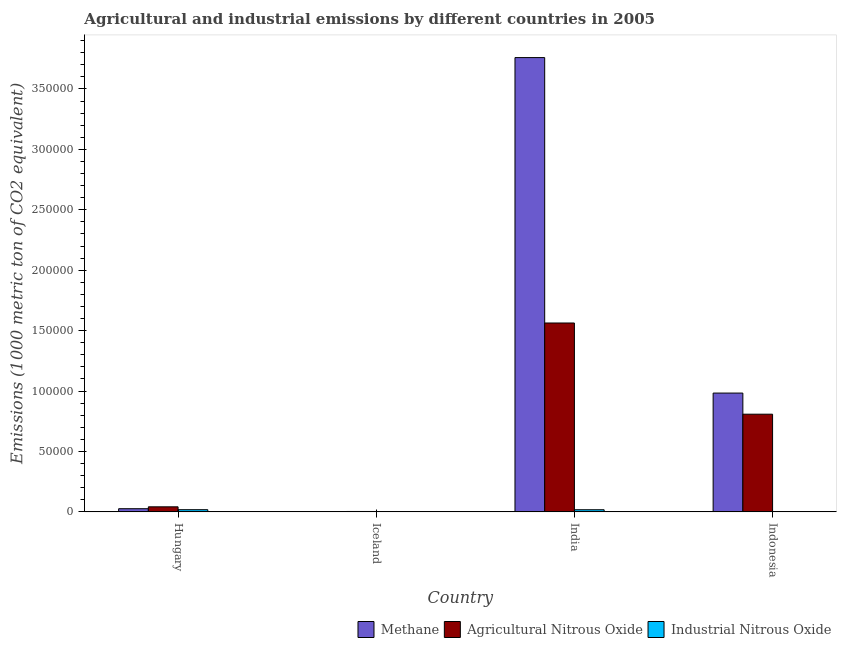How many different coloured bars are there?
Make the answer very short. 3. Are the number of bars per tick equal to the number of legend labels?
Ensure brevity in your answer.  Yes. Are the number of bars on each tick of the X-axis equal?
Keep it short and to the point. Yes. How many bars are there on the 4th tick from the right?
Provide a short and direct response. 3. What is the label of the 4th group of bars from the left?
Your response must be concise. Indonesia. In how many cases, is the number of bars for a given country not equal to the number of legend labels?
Provide a short and direct response. 0. What is the amount of industrial nitrous oxide emissions in Indonesia?
Your answer should be compact. 219.6. Across all countries, what is the maximum amount of industrial nitrous oxide emissions?
Ensure brevity in your answer.  1802. Across all countries, what is the minimum amount of methane emissions?
Provide a short and direct response. 214.9. In which country was the amount of methane emissions maximum?
Give a very brief answer. India. What is the total amount of industrial nitrous oxide emissions in the graph?
Your answer should be compact. 3798.8. What is the difference between the amount of methane emissions in India and that in Indonesia?
Offer a very short reply. 2.78e+05. What is the difference between the amount of industrial nitrous oxide emissions in Indonesia and the amount of methane emissions in Hungary?
Make the answer very short. -2393.4. What is the average amount of agricultural nitrous oxide emissions per country?
Give a very brief answer. 6.04e+04. What is the difference between the amount of methane emissions and amount of industrial nitrous oxide emissions in India?
Your answer should be very brief. 3.74e+05. What is the ratio of the amount of industrial nitrous oxide emissions in Iceland to that in Indonesia?
Your answer should be very brief. 0.07. Is the difference between the amount of industrial nitrous oxide emissions in Iceland and Indonesia greater than the difference between the amount of agricultural nitrous oxide emissions in Iceland and Indonesia?
Ensure brevity in your answer.  Yes. What is the difference between the highest and the second highest amount of agricultural nitrous oxide emissions?
Make the answer very short. 7.55e+04. What is the difference between the highest and the lowest amount of methane emissions?
Give a very brief answer. 3.76e+05. In how many countries, is the amount of agricultural nitrous oxide emissions greater than the average amount of agricultural nitrous oxide emissions taken over all countries?
Your answer should be very brief. 2. Is the sum of the amount of methane emissions in Hungary and Iceland greater than the maximum amount of industrial nitrous oxide emissions across all countries?
Offer a very short reply. Yes. What does the 1st bar from the left in Hungary represents?
Provide a succinct answer. Methane. What does the 1st bar from the right in Iceland represents?
Provide a short and direct response. Industrial Nitrous Oxide. How many bars are there?
Your answer should be very brief. 12. Are all the bars in the graph horizontal?
Provide a succinct answer. No. What is the difference between two consecutive major ticks on the Y-axis?
Provide a short and direct response. 5.00e+04. Are the values on the major ticks of Y-axis written in scientific E-notation?
Offer a terse response. No. Does the graph contain any zero values?
Provide a short and direct response. No. Does the graph contain grids?
Provide a short and direct response. No. How are the legend labels stacked?
Provide a short and direct response. Horizontal. What is the title of the graph?
Ensure brevity in your answer.  Agricultural and industrial emissions by different countries in 2005. What is the label or title of the Y-axis?
Offer a very short reply. Emissions (1000 metric ton of CO2 equivalent). What is the Emissions (1000 metric ton of CO2 equivalent) of Methane in Hungary?
Offer a terse response. 2613. What is the Emissions (1000 metric ton of CO2 equivalent) of Agricultural Nitrous Oxide in Hungary?
Your response must be concise. 4181.2. What is the Emissions (1000 metric ton of CO2 equivalent) of Industrial Nitrous Oxide in Hungary?
Provide a succinct answer. 1802. What is the Emissions (1000 metric ton of CO2 equivalent) of Methane in Iceland?
Ensure brevity in your answer.  214.9. What is the Emissions (1000 metric ton of CO2 equivalent) of Agricultural Nitrous Oxide in Iceland?
Your answer should be compact. 332.8. What is the Emissions (1000 metric ton of CO2 equivalent) of Industrial Nitrous Oxide in Iceland?
Your answer should be very brief. 15.3. What is the Emissions (1000 metric ton of CO2 equivalent) in Methane in India?
Give a very brief answer. 3.76e+05. What is the Emissions (1000 metric ton of CO2 equivalent) of Agricultural Nitrous Oxide in India?
Provide a short and direct response. 1.56e+05. What is the Emissions (1000 metric ton of CO2 equivalent) of Industrial Nitrous Oxide in India?
Keep it short and to the point. 1761.9. What is the Emissions (1000 metric ton of CO2 equivalent) of Methane in Indonesia?
Your response must be concise. 9.83e+04. What is the Emissions (1000 metric ton of CO2 equivalent) in Agricultural Nitrous Oxide in Indonesia?
Offer a very short reply. 8.08e+04. What is the Emissions (1000 metric ton of CO2 equivalent) in Industrial Nitrous Oxide in Indonesia?
Provide a short and direct response. 219.6. Across all countries, what is the maximum Emissions (1000 metric ton of CO2 equivalent) of Methane?
Make the answer very short. 3.76e+05. Across all countries, what is the maximum Emissions (1000 metric ton of CO2 equivalent) of Agricultural Nitrous Oxide?
Your response must be concise. 1.56e+05. Across all countries, what is the maximum Emissions (1000 metric ton of CO2 equivalent) of Industrial Nitrous Oxide?
Give a very brief answer. 1802. Across all countries, what is the minimum Emissions (1000 metric ton of CO2 equivalent) in Methane?
Give a very brief answer. 214.9. Across all countries, what is the minimum Emissions (1000 metric ton of CO2 equivalent) in Agricultural Nitrous Oxide?
Offer a very short reply. 332.8. Across all countries, what is the minimum Emissions (1000 metric ton of CO2 equivalent) in Industrial Nitrous Oxide?
Keep it short and to the point. 15.3. What is the total Emissions (1000 metric ton of CO2 equivalent) of Methane in the graph?
Keep it short and to the point. 4.77e+05. What is the total Emissions (1000 metric ton of CO2 equivalent) of Agricultural Nitrous Oxide in the graph?
Offer a terse response. 2.42e+05. What is the total Emissions (1000 metric ton of CO2 equivalent) in Industrial Nitrous Oxide in the graph?
Your response must be concise. 3798.8. What is the difference between the Emissions (1000 metric ton of CO2 equivalent) in Methane in Hungary and that in Iceland?
Your response must be concise. 2398.1. What is the difference between the Emissions (1000 metric ton of CO2 equivalent) in Agricultural Nitrous Oxide in Hungary and that in Iceland?
Offer a terse response. 3848.4. What is the difference between the Emissions (1000 metric ton of CO2 equivalent) in Industrial Nitrous Oxide in Hungary and that in Iceland?
Ensure brevity in your answer.  1786.7. What is the difference between the Emissions (1000 metric ton of CO2 equivalent) of Methane in Hungary and that in India?
Provide a short and direct response. -3.73e+05. What is the difference between the Emissions (1000 metric ton of CO2 equivalent) in Agricultural Nitrous Oxide in Hungary and that in India?
Your answer should be compact. -1.52e+05. What is the difference between the Emissions (1000 metric ton of CO2 equivalent) of Industrial Nitrous Oxide in Hungary and that in India?
Make the answer very short. 40.1. What is the difference between the Emissions (1000 metric ton of CO2 equivalent) in Methane in Hungary and that in Indonesia?
Provide a succinct answer. -9.57e+04. What is the difference between the Emissions (1000 metric ton of CO2 equivalent) of Agricultural Nitrous Oxide in Hungary and that in Indonesia?
Provide a succinct answer. -7.66e+04. What is the difference between the Emissions (1000 metric ton of CO2 equivalent) of Industrial Nitrous Oxide in Hungary and that in Indonesia?
Ensure brevity in your answer.  1582.4. What is the difference between the Emissions (1000 metric ton of CO2 equivalent) of Methane in Iceland and that in India?
Give a very brief answer. -3.76e+05. What is the difference between the Emissions (1000 metric ton of CO2 equivalent) in Agricultural Nitrous Oxide in Iceland and that in India?
Make the answer very short. -1.56e+05. What is the difference between the Emissions (1000 metric ton of CO2 equivalent) in Industrial Nitrous Oxide in Iceland and that in India?
Offer a terse response. -1746.6. What is the difference between the Emissions (1000 metric ton of CO2 equivalent) of Methane in Iceland and that in Indonesia?
Your response must be concise. -9.81e+04. What is the difference between the Emissions (1000 metric ton of CO2 equivalent) of Agricultural Nitrous Oxide in Iceland and that in Indonesia?
Offer a terse response. -8.05e+04. What is the difference between the Emissions (1000 metric ton of CO2 equivalent) in Industrial Nitrous Oxide in Iceland and that in Indonesia?
Your response must be concise. -204.3. What is the difference between the Emissions (1000 metric ton of CO2 equivalent) of Methane in India and that in Indonesia?
Ensure brevity in your answer.  2.78e+05. What is the difference between the Emissions (1000 metric ton of CO2 equivalent) of Agricultural Nitrous Oxide in India and that in Indonesia?
Offer a terse response. 7.55e+04. What is the difference between the Emissions (1000 metric ton of CO2 equivalent) in Industrial Nitrous Oxide in India and that in Indonesia?
Make the answer very short. 1542.3. What is the difference between the Emissions (1000 metric ton of CO2 equivalent) in Methane in Hungary and the Emissions (1000 metric ton of CO2 equivalent) in Agricultural Nitrous Oxide in Iceland?
Provide a succinct answer. 2280.2. What is the difference between the Emissions (1000 metric ton of CO2 equivalent) in Methane in Hungary and the Emissions (1000 metric ton of CO2 equivalent) in Industrial Nitrous Oxide in Iceland?
Offer a terse response. 2597.7. What is the difference between the Emissions (1000 metric ton of CO2 equivalent) in Agricultural Nitrous Oxide in Hungary and the Emissions (1000 metric ton of CO2 equivalent) in Industrial Nitrous Oxide in Iceland?
Your answer should be very brief. 4165.9. What is the difference between the Emissions (1000 metric ton of CO2 equivalent) in Methane in Hungary and the Emissions (1000 metric ton of CO2 equivalent) in Agricultural Nitrous Oxide in India?
Provide a succinct answer. -1.54e+05. What is the difference between the Emissions (1000 metric ton of CO2 equivalent) in Methane in Hungary and the Emissions (1000 metric ton of CO2 equivalent) in Industrial Nitrous Oxide in India?
Keep it short and to the point. 851.1. What is the difference between the Emissions (1000 metric ton of CO2 equivalent) in Agricultural Nitrous Oxide in Hungary and the Emissions (1000 metric ton of CO2 equivalent) in Industrial Nitrous Oxide in India?
Your response must be concise. 2419.3. What is the difference between the Emissions (1000 metric ton of CO2 equivalent) in Methane in Hungary and the Emissions (1000 metric ton of CO2 equivalent) in Agricultural Nitrous Oxide in Indonesia?
Make the answer very short. -7.82e+04. What is the difference between the Emissions (1000 metric ton of CO2 equivalent) in Methane in Hungary and the Emissions (1000 metric ton of CO2 equivalent) in Industrial Nitrous Oxide in Indonesia?
Give a very brief answer. 2393.4. What is the difference between the Emissions (1000 metric ton of CO2 equivalent) of Agricultural Nitrous Oxide in Hungary and the Emissions (1000 metric ton of CO2 equivalent) of Industrial Nitrous Oxide in Indonesia?
Provide a short and direct response. 3961.6. What is the difference between the Emissions (1000 metric ton of CO2 equivalent) of Methane in Iceland and the Emissions (1000 metric ton of CO2 equivalent) of Agricultural Nitrous Oxide in India?
Your answer should be compact. -1.56e+05. What is the difference between the Emissions (1000 metric ton of CO2 equivalent) of Methane in Iceland and the Emissions (1000 metric ton of CO2 equivalent) of Industrial Nitrous Oxide in India?
Give a very brief answer. -1547. What is the difference between the Emissions (1000 metric ton of CO2 equivalent) in Agricultural Nitrous Oxide in Iceland and the Emissions (1000 metric ton of CO2 equivalent) in Industrial Nitrous Oxide in India?
Offer a terse response. -1429.1. What is the difference between the Emissions (1000 metric ton of CO2 equivalent) of Methane in Iceland and the Emissions (1000 metric ton of CO2 equivalent) of Agricultural Nitrous Oxide in Indonesia?
Provide a short and direct response. -8.06e+04. What is the difference between the Emissions (1000 metric ton of CO2 equivalent) of Methane in Iceland and the Emissions (1000 metric ton of CO2 equivalent) of Industrial Nitrous Oxide in Indonesia?
Ensure brevity in your answer.  -4.7. What is the difference between the Emissions (1000 metric ton of CO2 equivalent) in Agricultural Nitrous Oxide in Iceland and the Emissions (1000 metric ton of CO2 equivalent) in Industrial Nitrous Oxide in Indonesia?
Your answer should be very brief. 113.2. What is the difference between the Emissions (1000 metric ton of CO2 equivalent) of Methane in India and the Emissions (1000 metric ton of CO2 equivalent) of Agricultural Nitrous Oxide in Indonesia?
Your response must be concise. 2.95e+05. What is the difference between the Emissions (1000 metric ton of CO2 equivalent) of Methane in India and the Emissions (1000 metric ton of CO2 equivalent) of Industrial Nitrous Oxide in Indonesia?
Provide a short and direct response. 3.76e+05. What is the difference between the Emissions (1000 metric ton of CO2 equivalent) of Agricultural Nitrous Oxide in India and the Emissions (1000 metric ton of CO2 equivalent) of Industrial Nitrous Oxide in Indonesia?
Ensure brevity in your answer.  1.56e+05. What is the average Emissions (1000 metric ton of CO2 equivalent) in Methane per country?
Give a very brief answer. 1.19e+05. What is the average Emissions (1000 metric ton of CO2 equivalent) in Agricultural Nitrous Oxide per country?
Offer a terse response. 6.04e+04. What is the average Emissions (1000 metric ton of CO2 equivalent) of Industrial Nitrous Oxide per country?
Your answer should be very brief. 949.7. What is the difference between the Emissions (1000 metric ton of CO2 equivalent) of Methane and Emissions (1000 metric ton of CO2 equivalent) of Agricultural Nitrous Oxide in Hungary?
Your answer should be compact. -1568.2. What is the difference between the Emissions (1000 metric ton of CO2 equivalent) in Methane and Emissions (1000 metric ton of CO2 equivalent) in Industrial Nitrous Oxide in Hungary?
Provide a short and direct response. 811. What is the difference between the Emissions (1000 metric ton of CO2 equivalent) in Agricultural Nitrous Oxide and Emissions (1000 metric ton of CO2 equivalent) in Industrial Nitrous Oxide in Hungary?
Offer a terse response. 2379.2. What is the difference between the Emissions (1000 metric ton of CO2 equivalent) of Methane and Emissions (1000 metric ton of CO2 equivalent) of Agricultural Nitrous Oxide in Iceland?
Ensure brevity in your answer.  -117.9. What is the difference between the Emissions (1000 metric ton of CO2 equivalent) in Methane and Emissions (1000 metric ton of CO2 equivalent) in Industrial Nitrous Oxide in Iceland?
Offer a very short reply. 199.6. What is the difference between the Emissions (1000 metric ton of CO2 equivalent) in Agricultural Nitrous Oxide and Emissions (1000 metric ton of CO2 equivalent) in Industrial Nitrous Oxide in Iceland?
Your answer should be compact. 317.5. What is the difference between the Emissions (1000 metric ton of CO2 equivalent) in Methane and Emissions (1000 metric ton of CO2 equivalent) in Agricultural Nitrous Oxide in India?
Give a very brief answer. 2.20e+05. What is the difference between the Emissions (1000 metric ton of CO2 equivalent) of Methane and Emissions (1000 metric ton of CO2 equivalent) of Industrial Nitrous Oxide in India?
Keep it short and to the point. 3.74e+05. What is the difference between the Emissions (1000 metric ton of CO2 equivalent) in Agricultural Nitrous Oxide and Emissions (1000 metric ton of CO2 equivalent) in Industrial Nitrous Oxide in India?
Keep it short and to the point. 1.55e+05. What is the difference between the Emissions (1000 metric ton of CO2 equivalent) of Methane and Emissions (1000 metric ton of CO2 equivalent) of Agricultural Nitrous Oxide in Indonesia?
Your answer should be compact. 1.75e+04. What is the difference between the Emissions (1000 metric ton of CO2 equivalent) in Methane and Emissions (1000 metric ton of CO2 equivalent) in Industrial Nitrous Oxide in Indonesia?
Offer a terse response. 9.81e+04. What is the difference between the Emissions (1000 metric ton of CO2 equivalent) in Agricultural Nitrous Oxide and Emissions (1000 metric ton of CO2 equivalent) in Industrial Nitrous Oxide in Indonesia?
Offer a very short reply. 8.06e+04. What is the ratio of the Emissions (1000 metric ton of CO2 equivalent) in Methane in Hungary to that in Iceland?
Ensure brevity in your answer.  12.16. What is the ratio of the Emissions (1000 metric ton of CO2 equivalent) in Agricultural Nitrous Oxide in Hungary to that in Iceland?
Your answer should be compact. 12.56. What is the ratio of the Emissions (1000 metric ton of CO2 equivalent) in Industrial Nitrous Oxide in Hungary to that in Iceland?
Keep it short and to the point. 117.78. What is the ratio of the Emissions (1000 metric ton of CO2 equivalent) of Methane in Hungary to that in India?
Offer a very short reply. 0.01. What is the ratio of the Emissions (1000 metric ton of CO2 equivalent) in Agricultural Nitrous Oxide in Hungary to that in India?
Give a very brief answer. 0.03. What is the ratio of the Emissions (1000 metric ton of CO2 equivalent) in Industrial Nitrous Oxide in Hungary to that in India?
Make the answer very short. 1.02. What is the ratio of the Emissions (1000 metric ton of CO2 equivalent) of Methane in Hungary to that in Indonesia?
Provide a succinct answer. 0.03. What is the ratio of the Emissions (1000 metric ton of CO2 equivalent) in Agricultural Nitrous Oxide in Hungary to that in Indonesia?
Your answer should be very brief. 0.05. What is the ratio of the Emissions (1000 metric ton of CO2 equivalent) of Industrial Nitrous Oxide in Hungary to that in Indonesia?
Give a very brief answer. 8.21. What is the ratio of the Emissions (1000 metric ton of CO2 equivalent) of Methane in Iceland to that in India?
Offer a terse response. 0. What is the ratio of the Emissions (1000 metric ton of CO2 equivalent) in Agricultural Nitrous Oxide in Iceland to that in India?
Your answer should be compact. 0. What is the ratio of the Emissions (1000 metric ton of CO2 equivalent) of Industrial Nitrous Oxide in Iceland to that in India?
Your response must be concise. 0.01. What is the ratio of the Emissions (1000 metric ton of CO2 equivalent) in Methane in Iceland to that in Indonesia?
Provide a succinct answer. 0. What is the ratio of the Emissions (1000 metric ton of CO2 equivalent) of Agricultural Nitrous Oxide in Iceland to that in Indonesia?
Offer a terse response. 0. What is the ratio of the Emissions (1000 metric ton of CO2 equivalent) in Industrial Nitrous Oxide in Iceland to that in Indonesia?
Make the answer very short. 0.07. What is the ratio of the Emissions (1000 metric ton of CO2 equivalent) of Methane in India to that in Indonesia?
Give a very brief answer. 3.82. What is the ratio of the Emissions (1000 metric ton of CO2 equivalent) of Agricultural Nitrous Oxide in India to that in Indonesia?
Make the answer very short. 1.93. What is the ratio of the Emissions (1000 metric ton of CO2 equivalent) in Industrial Nitrous Oxide in India to that in Indonesia?
Your response must be concise. 8.02. What is the difference between the highest and the second highest Emissions (1000 metric ton of CO2 equivalent) of Methane?
Provide a short and direct response. 2.78e+05. What is the difference between the highest and the second highest Emissions (1000 metric ton of CO2 equivalent) of Agricultural Nitrous Oxide?
Your response must be concise. 7.55e+04. What is the difference between the highest and the second highest Emissions (1000 metric ton of CO2 equivalent) of Industrial Nitrous Oxide?
Provide a short and direct response. 40.1. What is the difference between the highest and the lowest Emissions (1000 metric ton of CO2 equivalent) in Methane?
Offer a very short reply. 3.76e+05. What is the difference between the highest and the lowest Emissions (1000 metric ton of CO2 equivalent) of Agricultural Nitrous Oxide?
Make the answer very short. 1.56e+05. What is the difference between the highest and the lowest Emissions (1000 metric ton of CO2 equivalent) of Industrial Nitrous Oxide?
Provide a short and direct response. 1786.7. 